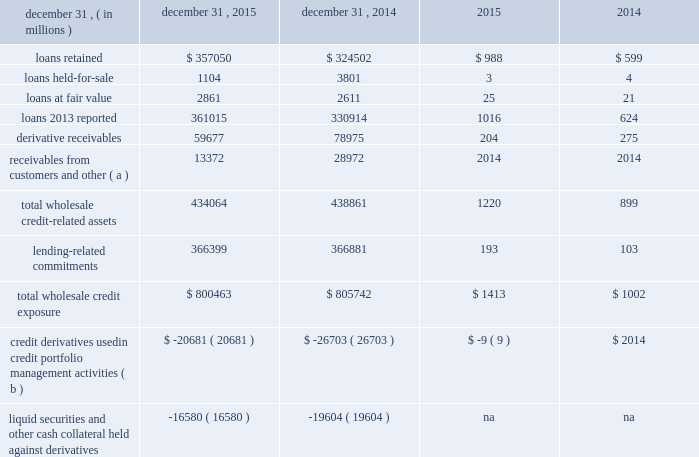Management 2019s discussion and analysis 122 jpmorgan chase & co./2015 annual report wholesale credit portfolio the firm 2019s wholesale businesses are exposed to credit risk through underwriting , lending , market-making , and hedging activities with and for clients and counterparties , as well as through various operating services such as cash management and clearing activities .
A portion of the loans originated or acquired by the firm 2019s wholesale businesses is generally retained on the balance sheet .
The firm distributes a significant percentage of the loans it originates into the market as part of its syndicated loan business and to manage portfolio concentrations and credit risk .
The wholesale credit portfolio , excluding oil & gas , continued to be generally stable throughout 2015 , characterized by low levels of criticized exposure , nonaccrual loans and charge-offs .
Growth in loans retained was driven by increased client activity , notably in commercial real estate .
Discipline in underwriting across all areas of lending continues to remain a key point of focus .
The wholesale portfolio is actively managed , in part by conducting ongoing , in-depth reviews of client credit quality and transaction structure , inclusive of collateral where applicable ; and of industry , product and client concentrations .
Wholesale credit portfolio december 31 , credit exposure nonperforming ( c ) .
Receivables from customers and other ( a ) 13372 28972 2014 2014 total wholesale credit- related assets 434064 438861 1220 899 lending-related commitments 366399 366881 193 103 total wholesale credit exposure $ 800463 $ 805742 $ 1413 $ 1002 credit derivatives used in credit portfolio management activities ( b ) $ ( 20681 ) $ ( 26703 ) $ ( 9 ) $ 2014 liquid securities and other cash collateral held against derivatives ( 16580 ) ( 19604 ) na na ( a ) receivables from customers and other include $ 13.3 billion and $ 28.8 billion of margin loans at december 31 , 2015 and 2014 , respectively , to prime and retail brokerage customers ; these are classified in accrued interest and accounts receivable on the consolidated balance sheets .
( b ) represents the net notional amount of protection purchased and sold through credit derivatives used to manage both performing and nonperforming wholesale credit exposures ; these derivatives do not qualify for hedge accounting under u.s .
Gaap .
For additional information , see credit derivatives on page 129 , and note 6 .
( c ) excludes assets acquired in loan satisfactions. .
What was the percentage change in loans retained from 2014 to 2015? 
Computations: ((357050 - 324502) / 324502)
Answer: 0.1003. 